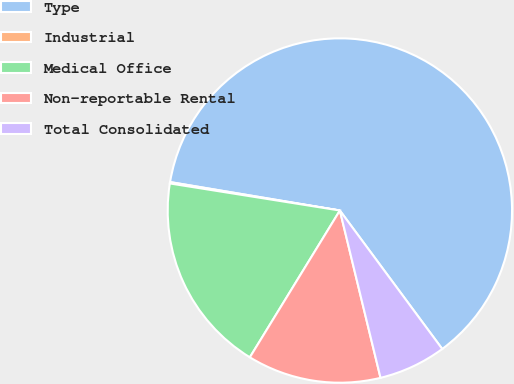Convert chart to OTSL. <chart><loc_0><loc_0><loc_500><loc_500><pie_chart><fcel>Type<fcel>Industrial<fcel>Medical Office<fcel>Non-reportable Rental<fcel>Total Consolidated<nl><fcel>62.23%<fcel>0.13%<fcel>18.76%<fcel>12.55%<fcel>6.34%<nl></chart> 